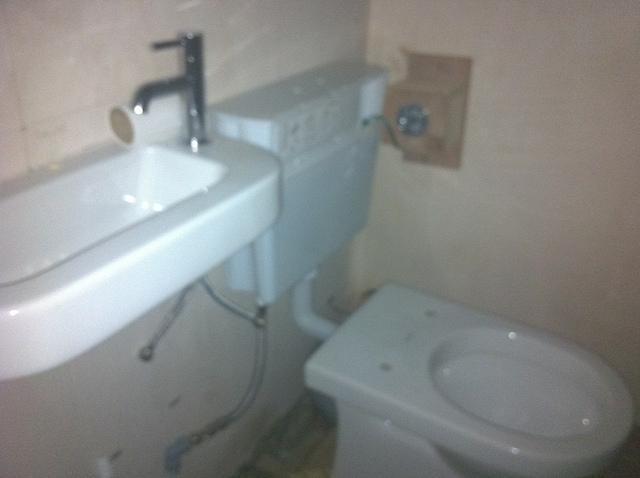How many train tracks are shown?
Give a very brief answer. 0. 